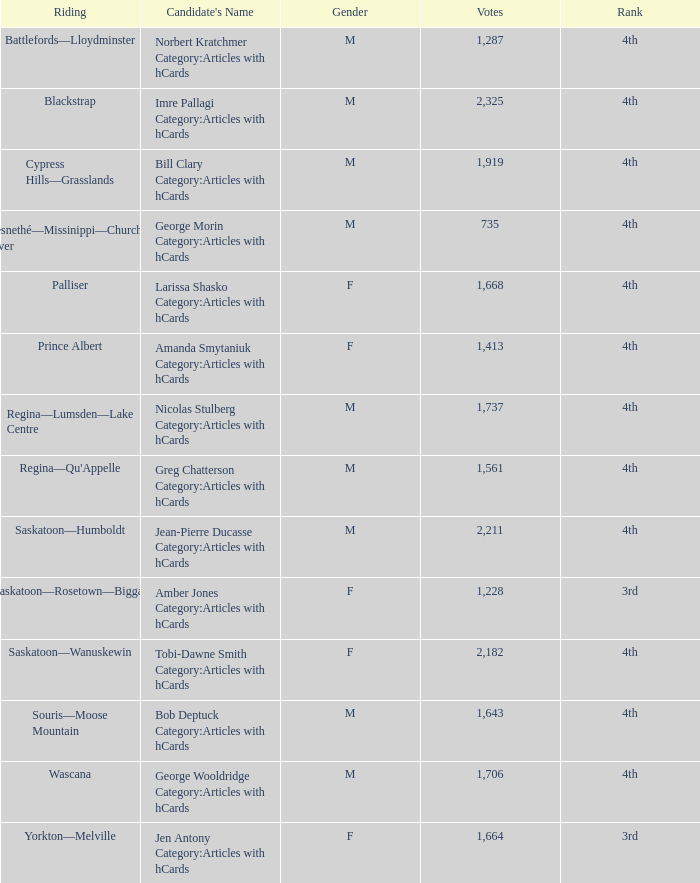What is the rank of the candidate with more than 2,211 votes? 4th. 